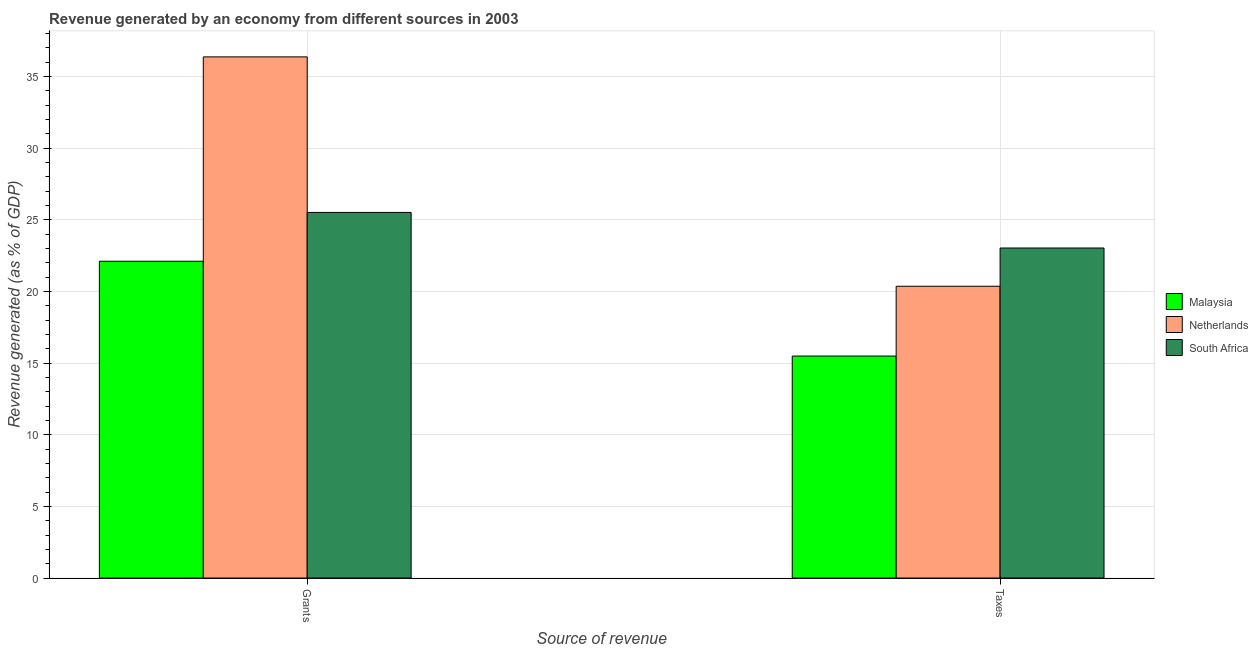Are the number of bars on each tick of the X-axis equal?
Offer a very short reply. Yes. How many bars are there on the 1st tick from the right?
Your answer should be compact. 3. What is the label of the 2nd group of bars from the left?
Make the answer very short. Taxes. What is the revenue generated by taxes in South Africa?
Give a very brief answer. 23.04. Across all countries, what is the maximum revenue generated by taxes?
Provide a short and direct response. 23.04. Across all countries, what is the minimum revenue generated by grants?
Give a very brief answer. 22.11. In which country was the revenue generated by taxes maximum?
Offer a terse response. South Africa. In which country was the revenue generated by taxes minimum?
Make the answer very short. Malaysia. What is the total revenue generated by taxes in the graph?
Offer a terse response. 58.9. What is the difference between the revenue generated by grants in Netherlands and that in South Africa?
Provide a succinct answer. 10.86. What is the difference between the revenue generated by grants in South Africa and the revenue generated by taxes in Netherlands?
Offer a very short reply. 5.15. What is the average revenue generated by grants per country?
Your answer should be very brief. 28.01. What is the difference between the revenue generated by taxes and revenue generated by grants in Netherlands?
Provide a succinct answer. -16.01. What is the ratio of the revenue generated by taxes in Netherlands to that in Malaysia?
Provide a short and direct response. 1.31. Is the revenue generated by taxes in South Africa less than that in Malaysia?
Provide a short and direct response. No. In how many countries, is the revenue generated by grants greater than the average revenue generated by grants taken over all countries?
Keep it short and to the point. 1. What does the 3rd bar from the left in Taxes represents?
Give a very brief answer. South Africa. What does the 3rd bar from the right in Grants represents?
Make the answer very short. Malaysia. Are all the bars in the graph horizontal?
Provide a short and direct response. No. What is the difference between two consecutive major ticks on the Y-axis?
Your answer should be compact. 5. Are the values on the major ticks of Y-axis written in scientific E-notation?
Your answer should be compact. No. Does the graph contain any zero values?
Make the answer very short. No. What is the title of the graph?
Give a very brief answer. Revenue generated by an economy from different sources in 2003. Does "Nepal" appear as one of the legend labels in the graph?
Offer a very short reply. No. What is the label or title of the X-axis?
Ensure brevity in your answer.  Source of revenue. What is the label or title of the Y-axis?
Provide a short and direct response. Revenue generated (as % of GDP). What is the Revenue generated (as % of GDP) in Malaysia in Grants?
Your answer should be compact. 22.11. What is the Revenue generated (as % of GDP) of Netherlands in Grants?
Ensure brevity in your answer.  36.38. What is the Revenue generated (as % of GDP) of South Africa in Grants?
Ensure brevity in your answer.  25.52. What is the Revenue generated (as % of GDP) of Malaysia in Taxes?
Your answer should be compact. 15.5. What is the Revenue generated (as % of GDP) of Netherlands in Taxes?
Offer a terse response. 20.37. What is the Revenue generated (as % of GDP) of South Africa in Taxes?
Offer a terse response. 23.04. Across all Source of revenue, what is the maximum Revenue generated (as % of GDP) of Malaysia?
Offer a very short reply. 22.11. Across all Source of revenue, what is the maximum Revenue generated (as % of GDP) of Netherlands?
Provide a short and direct response. 36.38. Across all Source of revenue, what is the maximum Revenue generated (as % of GDP) of South Africa?
Offer a very short reply. 25.52. Across all Source of revenue, what is the minimum Revenue generated (as % of GDP) of Malaysia?
Give a very brief answer. 15.5. Across all Source of revenue, what is the minimum Revenue generated (as % of GDP) of Netherlands?
Ensure brevity in your answer.  20.37. Across all Source of revenue, what is the minimum Revenue generated (as % of GDP) of South Africa?
Offer a terse response. 23.04. What is the total Revenue generated (as % of GDP) of Malaysia in the graph?
Your answer should be very brief. 37.61. What is the total Revenue generated (as % of GDP) in Netherlands in the graph?
Ensure brevity in your answer.  56.75. What is the total Revenue generated (as % of GDP) in South Africa in the graph?
Your answer should be very brief. 48.56. What is the difference between the Revenue generated (as % of GDP) in Malaysia in Grants and that in Taxes?
Offer a very short reply. 6.62. What is the difference between the Revenue generated (as % of GDP) of Netherlands in Grants and that in Taxes?
Ensure brevity in your answer.  16.01. What is the difference between the Revenue generated (as % of GDP) of South Africa in Grants and that in Taxes?
Offer a terse response. 2.48. What is the difference between the Revenue generated (as % of GDP) of Malaysia in Grants and the Revenue generated (as % of GDP) of Netherlands in Taxes?
Provide a succinct answer. 1.75. What is the difference between the Revenue generated (as % of GDP) of Malaysia in Grants and the Revenue generated (as % of GDP) of South Africa in Taxes?
Provide a succinct answer. -0.92. What is the difference between the Revenue generated (as % of GDP) of Netherlands in Grants and the Revenue generated (as % of GDP) of South Africa in Taxes?
Ensure brevity in your answer.  13.34. What is the average Revenue generated (as % of GDP) of Malaysia per Source of revenue?
Provide a short and direct response. 18.8. What is the average Revenue generated (as % of GDP) of Netherlands per Source of revenue?
Provide a short and direct response. 28.37. What is the average Revenue generated (as % of GDP) of South Africa per Source of revenue?
Provide a succinct answer. 24.28. What is the difference between the Revenue generated (as % of GDP) of Malaysia and Revenue generated (as % of GDP) of Netherlands in Grants?
Provide a succinct answer. -14.27. What is the difference between the Revenue generated (as % of GDP) of Malaysia and Revenue generated (as % of GDP) of South Africa in Grants?
Your answer should be compact. -3.41. What is the difference between the Revenue generated (as % of GDP) of Netherlands and Revenue generated (as % of GDP) of South Africa in Grants?
Your answer should be compact. 10.86. What is the difference between the Revenue generated (as % of GDP) in Malaysia and Revenue generated (as % of GDP) in Netherlands in Taxes?
Offer a terse response. -4.87. What is the difference between the Revenue generated (as % of GDP) of Malaysia and Revenue generated (as % of GDP) of South Africa in Taxes?
Keep it short and to the point. -7.54. What is the difference between the Revenue generated (as % of GDP) in Netherlands and Revenue generated (as % of GDP) in South Africa in Taxes?
Your answer should be very brief. -2.67. What is the ratio of the Revenue generated (as % of GDP) of Malaysia in Grants to that in Taxes?
Provide a succinct answer. 1.43. What is the ratio of the Revenue generated (as % of GDP) in Netherlands in Grants to that in Taxes?
Give a very brief answer. 1.79. What is the ratio of the Revenue generated (as % of GDP) in South Africa in Grants to that in Taxes?
Your answer should be compact. 1.11. What is the difference between the highest and the second highest Revenue generated (as % of GDP) in Malaysia?
Offer a terse response. 6.62. What is the difference between the highest and the second highest Revenue generated (as % of GDP) in Netherlands?
Ensure brevity in your answer.  16.01. What is the difference between the highest and the second highest Revenue generated (as % of GDP) of South Africa?
Your answer should be very brief. 2.48. What is the difference between the highest and the lowest Revenue generated (as % of GDP) of Malaysia?
Provide a short and direct response. 6.62. What is the difference between the highest and the lowest Revenue generated (as % of GDP) of Netherlands?
Provide a succinct answer. 16.01. What is the difference between the highest and the lowest Revenue generated (as % of GDP) of South Africa?
Offer a very short reply. 2.48. 